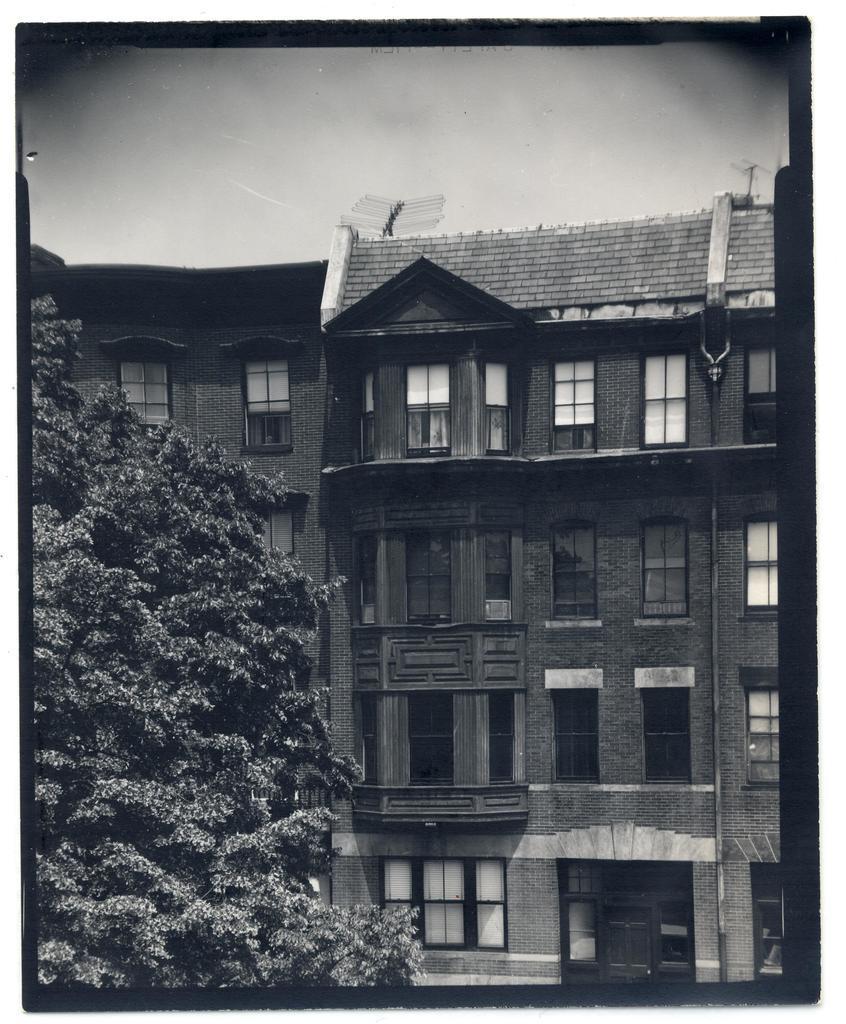How would you summarize this image in a sentence or two? In this picture we can see a tree, buildings with windows, doors, pipes and in the background we can see sky. 